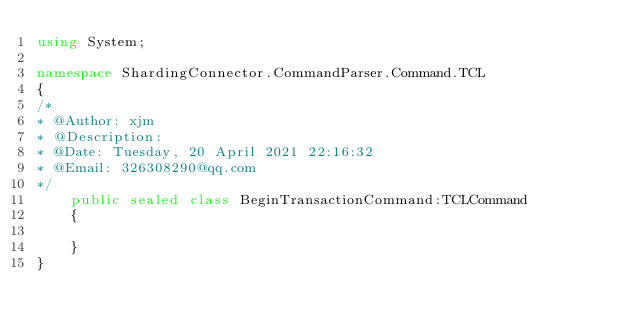<code> <loc_0><loc_0><loc_500><loc_500><_C#_>using System;

namespace ShardingConnector.CommandParser.Command.TCL
{
/*
* @Author: xjm
* @Description:
* @Date: Tuesday, 20 April 2021 22:16:32
* @Email: 326308290@qq.com
*/
    public sealed class BeginTransactionCommand:TCLCommand
    {
        
    }
}</code> 